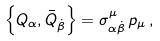<formula> <loc_0><loc_0><loc_500><loc_500>\left \{ Q _ { \alpha } , \bar { Q } _ { \dot { \beta } } \right \} = \sigma _ { \alpha \dot { \beta } } ^ { \mu } \, p _ { \mu } \, ,</formula> 